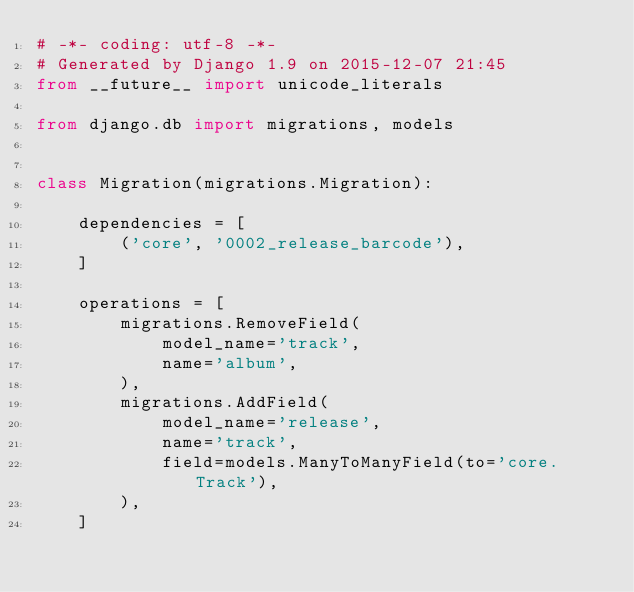Convert code to text. <code><loc_0><loc_0><loc_500><loc_500><_Python_># -*- coding: utf-8 -*-
# Generated by Django 1.9 on 2015-12-07 21:45
from __future__ import unicode_literals

from django.db import migrations, models


class Migration(migrations.Migration):

    dependencies = [
        ('core', '0002_release_barcode'),
    ]

    operations = [
        migrations.RemoveField(
            model_name='track',
            name='album',
        ),
        migrations.AddField(
            model_name='release',
            name='track',
            field=models.ManyToManyField(to='core.Track'),
        ),
    ]
</code> 